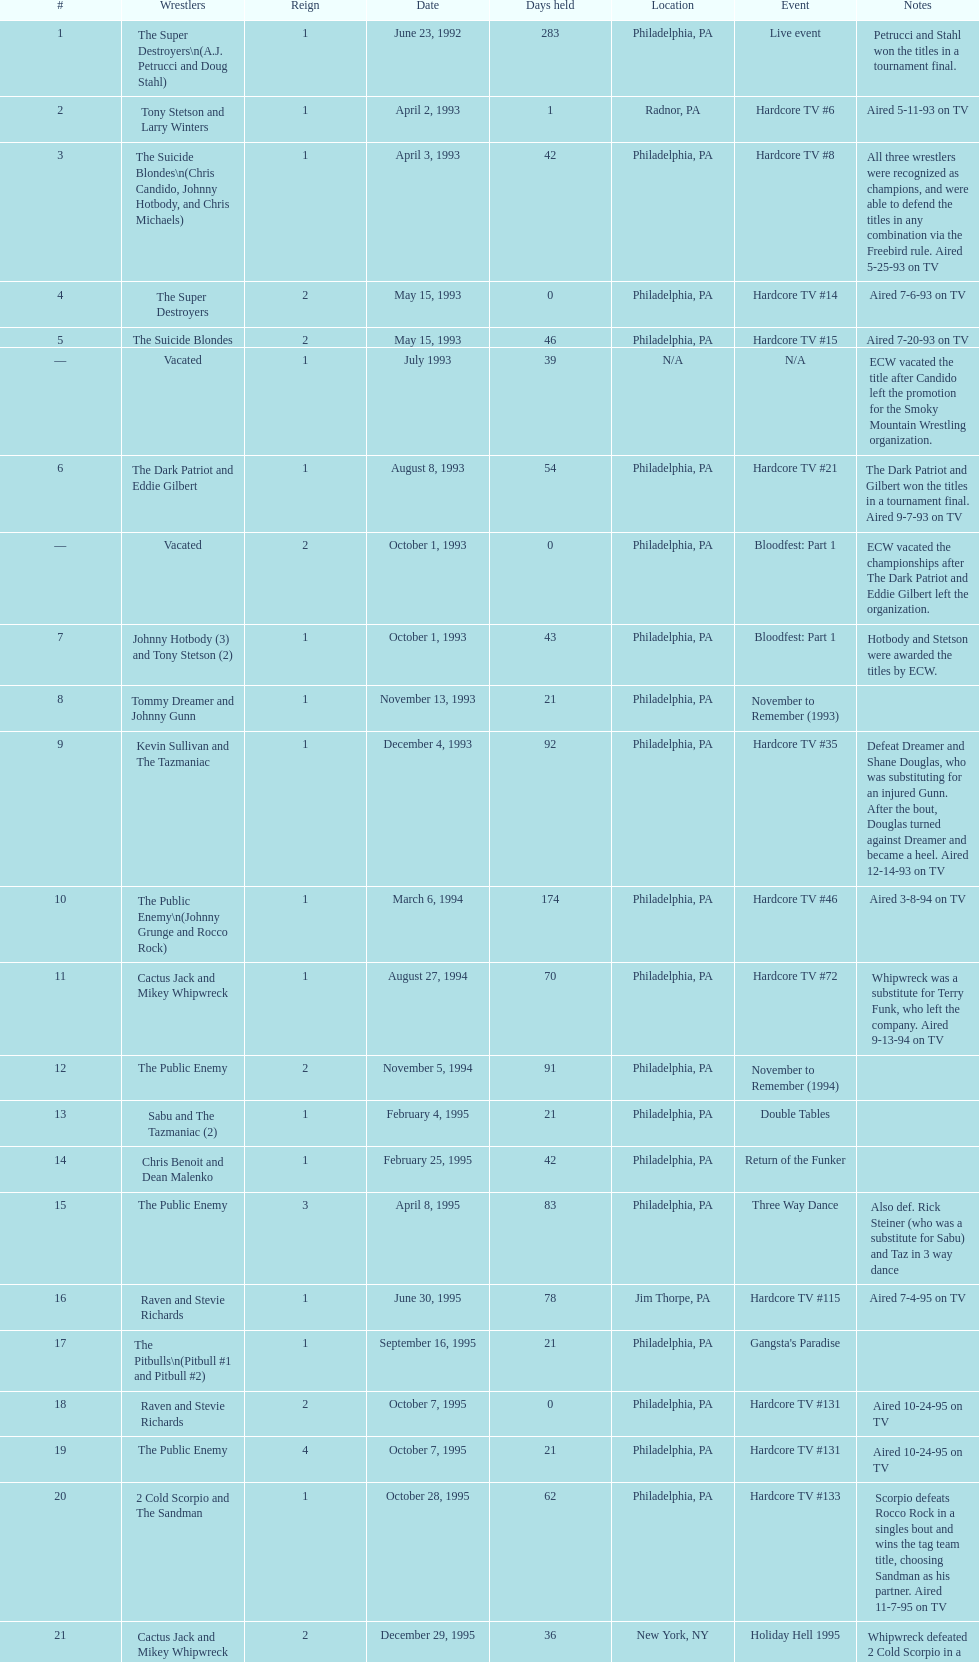What is the event that takes place right after hardcore tv #15? Hardcore TV #21. 